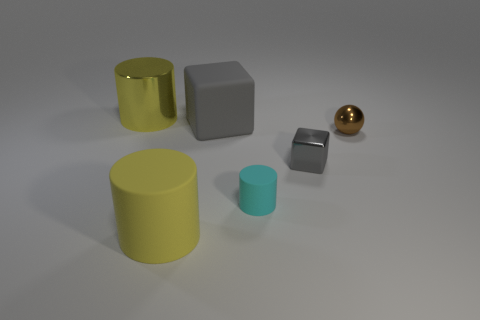Is the large metal cylinder the same color as the large rubber cylinder?
Ensure brevity in your answer.  Yes. What is the shape of the yellow object that is in front of the big cylinder to the left of the yellow matte cylinder?
Give a very brief answer. Cylinder. Is the number of tiny gray cubes less than the number of gray blocks?
Your answer should be very brief. Yes. There is a shiny thing that is both left of the tiny brown object and in front of the large gray thing; how big is it?
Make the answer very short. Small. Is the yellow matte object the same size as the brown sphere?
Your answer should be very brief. No. Do the big cylinder behind the sphere and the shiny block have the same color?
Offer a very short reply. No. There is a large rubber cube; what number of rubber things are in front of it?
Your response must be concise. 2. Is the number of big green rubber balls greater than the number of big matte blocks?
Offer a very short reply. No. The metal thing that is to the right of the yellow rubber cylinder and on the left side of the tiny brown shiny ball has what shape?
Make the answer very short. Cube. Are there any large gray balls?
Ensure brevity in your answer.  No. 